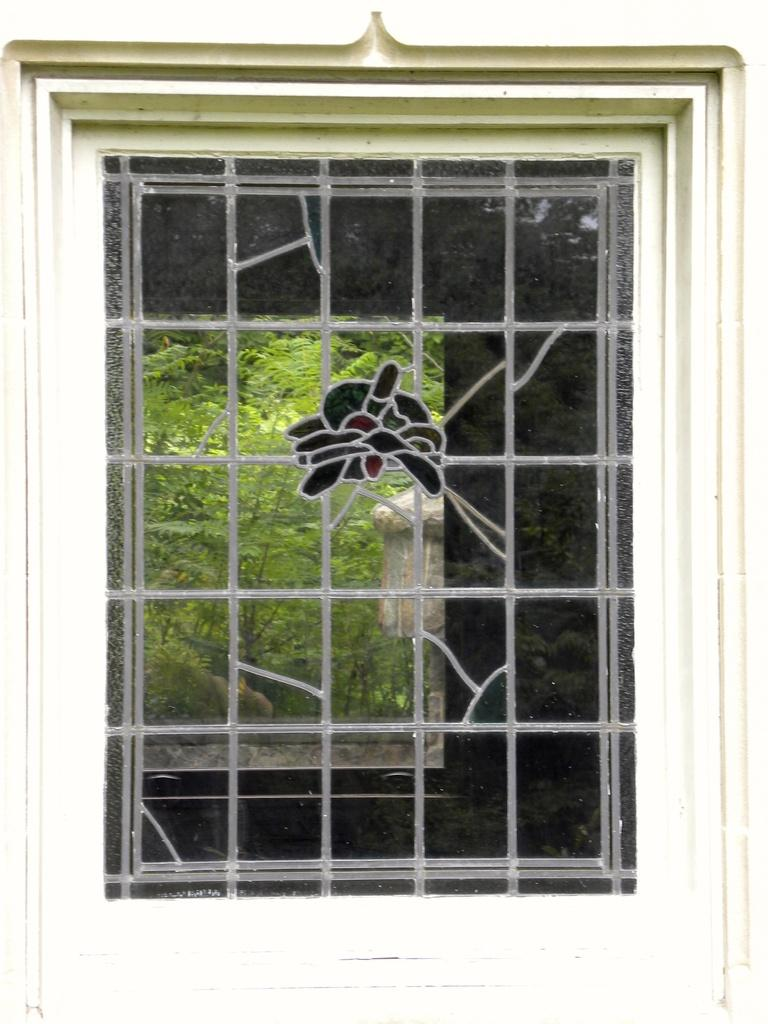What can be seen in the image? There is a window in the image. What is visible through the window? Trees are visible through the window. Can you see a snail crawling on the window in the image? There is no snail visible on the window in the image. 